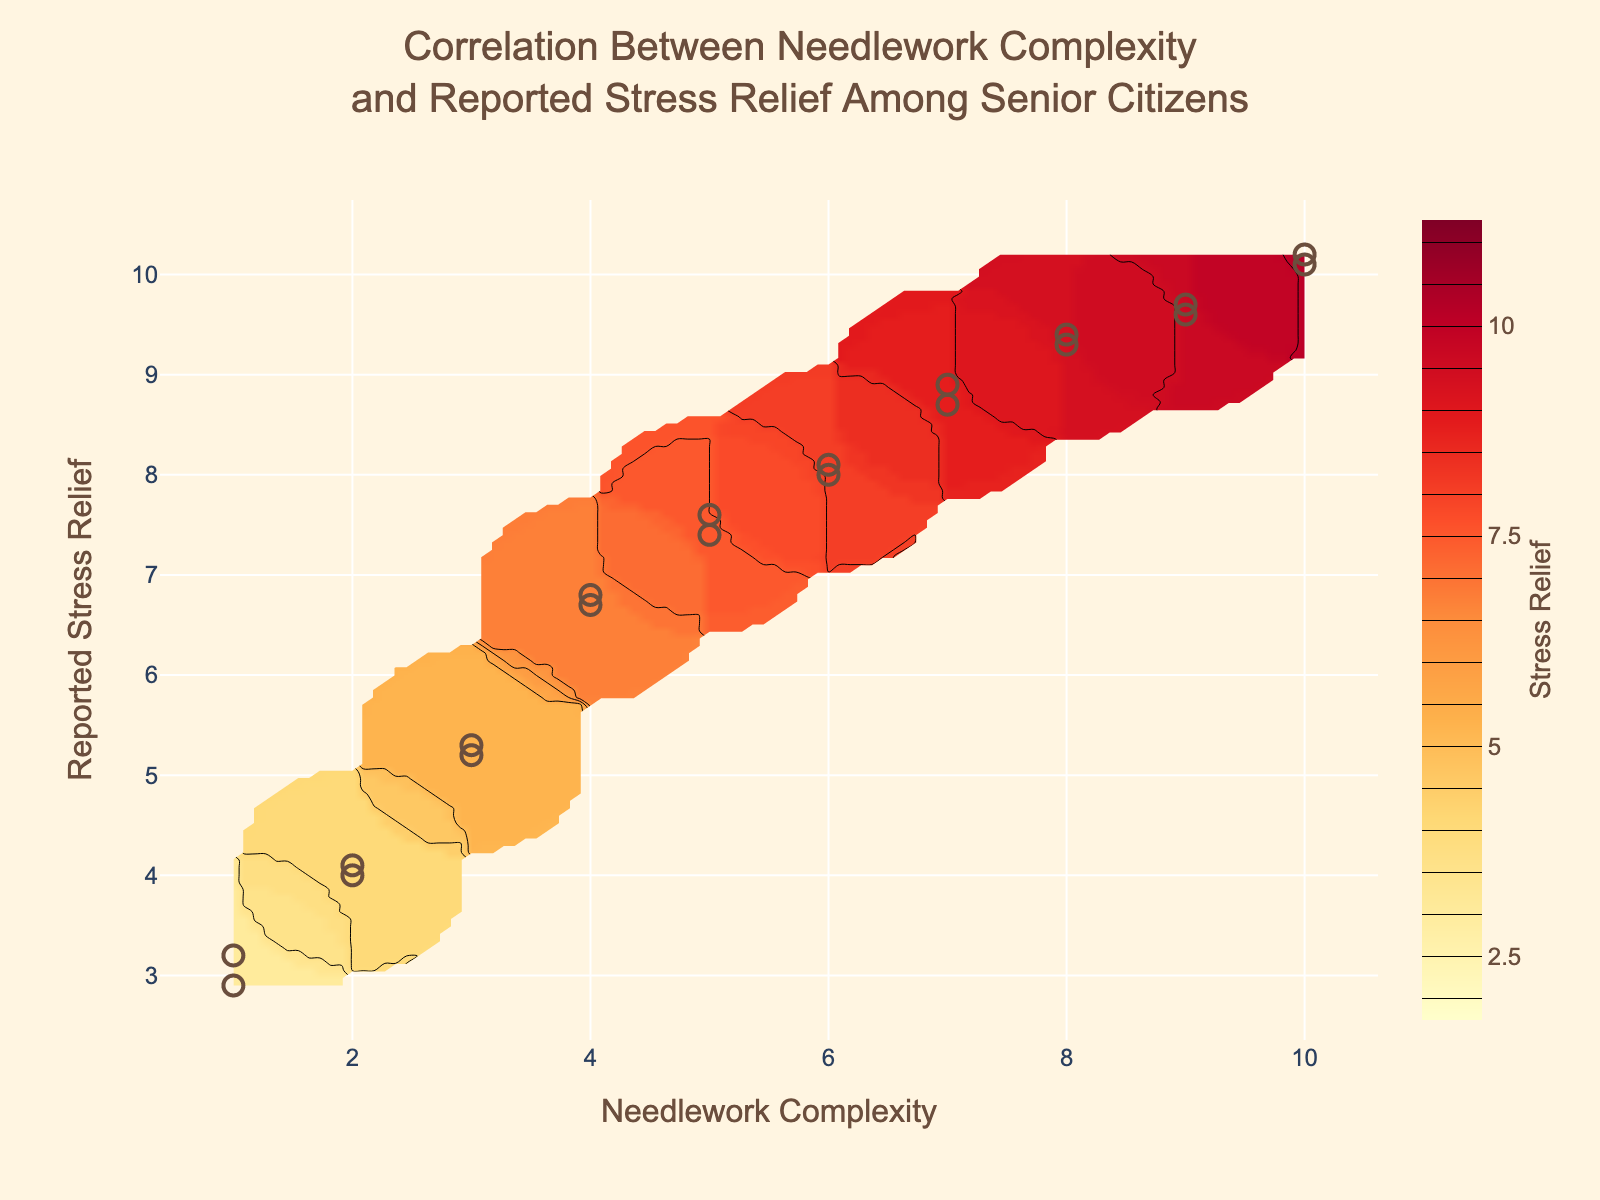What does the title of the figure indicate? The title "Correlation Between Needlework Complexity and Reported Stress Relief Among Senior Citizens" indicates that the figure explores how the complexity of needlework activities relates to the stress relief reported by senior citizens.
Answer: Correlation Between Needlework Complexity and Reported Stress Relief Among Senior Citizens What are the axes labeled as? The x-axis is labeled "Needlework Complexity," and the y-axis is labeled "Reported Stress Relief."
Answer: Needlework Complexity and Reported Stress Relief What colors are used in the plot, and what do they represent? The contour plot uses a range of colors from yellow to orange-red to represent different levels of stress relief, with lighter colors (yellow) representing lower stress relief and darker colors (orange-red) representing higher stress relief.
Answer: Yellow to orange-red How many data points are shown in the scatter plot? There are 20 data points shown in the scatter plot.
Answer: 20 What is the relationship between Needlework Complexity and Reported Stress Relief based on the contour plot? The contour plot shows that as Needlework Complexity increases, the Reported Stress Relief generally increases as well, suggesting a positive correlation.
Answer: Positive correlation What is the approximate range of Reported Stress Relief for a Needlework Complexity of 5? For a Needlework Complexity of 5, the contour plot shows that Reported Stress Relief ranges approximately between 7.4 and 7.6.
Answer: 7.4 to 7.6 How does the stress relief value change from a Needlework Complexity of 1 to a Needlework Complexity of 10? The plot shows that the Reported Stress Relief increases from around 3 to over 10 as the Needlework Complexity increases from 1 to 10.
Answer: Increases from around 3 to over 10 Comparing Needlework Complexities 3 and 6, which one provides higher average stress relief? The contour plot indicates that Needlework Complexity of 6 provides a higher average stress relief than 3, with values around 8 versus values around 5.3.
Answer: 6 For which Needlework Complexity range does Reported Stress Relief start to flatten out? The contour plot suggests that Reported Stress Relief starts to flatten out around a Needlework Complexity of 8 or higher.
Answer: Around 8 or higher What is the potential maximum stress relief value observed in the figure? The contour plot shows that the maximum observed stress relief value is slightly above 10, reaching around 10.2.
Answer: Around 10.2 